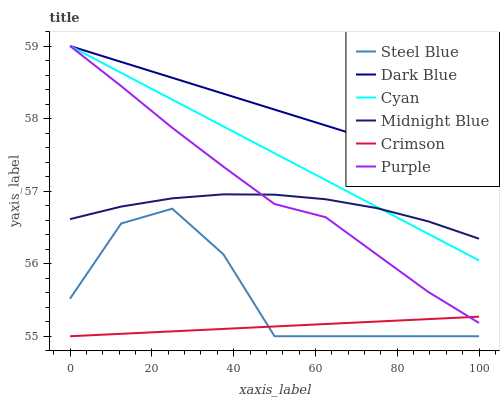Does Crimson have the minimum area under the curve?
Answer yes or no. Yes. Does Dark Blue have the maximum area under the curve?
Answer yes or no. Yes. Does Purple have the minimum area under the curve?
Answer yes or no. No. Does Purple have the maximum area under the curve?
Answer yes or no. No. Is Dark Blue the smoothest?
Answer yes or no. Yes. Is Steel Blue the roughest?
Answer yes or no. Yes. Is Purple the smoothest?
Answer yes or no. No. Is Purple the roughest?
Answer yes or no. No. Does Steel Blue have the lowest value?
Answer yes or no. Yes. Does Purple have the lowest value?
Answer yes or no. No. Does Cyan have the highest value?
Answer yes or no. Yes. Does Steel Blue have the highest value?
Answer yes or no. No. Is Crimson less than Cyan?
Answer yes or no. Yes. Is Dark Blue greater than Steel Blue?
Answer yes or no. Yes. Does Crimson intersect Steel Blue?
Answer yes or no. Yes. Is Crimson less than Steel Blue?
Answer yes or no. No. Is Crimson greater than Steel Blue?
Answer yes or no. No. Does Crimson intersect Cyan?
Answer yes or no. No. 